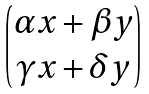Convert formula to latex. <formula><loc_0><loc_0><loc_500><loc_500>\begin{pmatrix} \alpha x + \beta y \\ \gamma x + \delta y \end{pmatrix}</formula> 